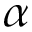<formula> <loc_0><loc_0><loc_500><loc_500>\alpha</formula> 